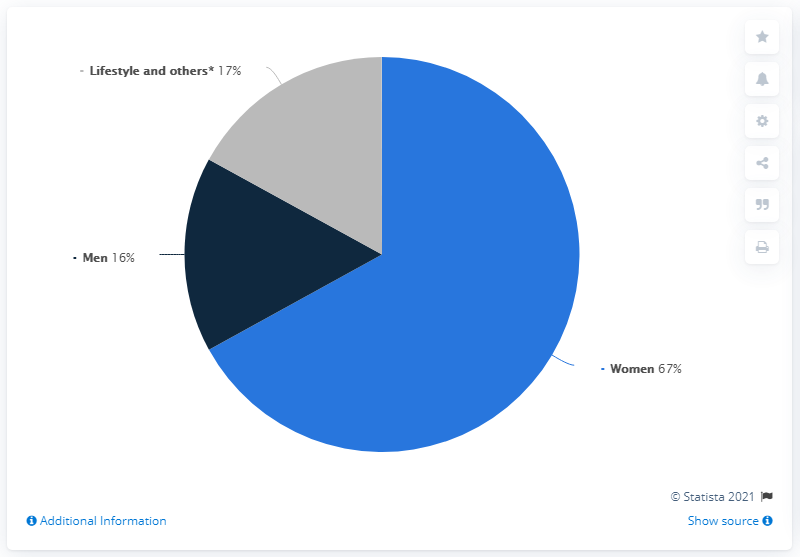Mention a couple of crucial points in this snapshot. The median value of all the segments in the pie chart is 17%. In the fiscal year 2019/2020, the percentage value of sales shares of the Men ESPRIT brand worldwide was 16%. In the 2019/2020 fiscal year, the women category accounted for 67% of total sales. 